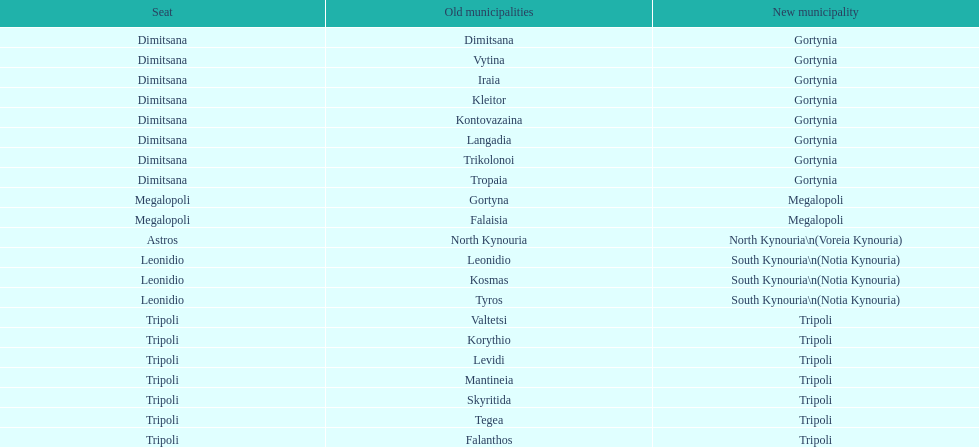What is the new municipality of tyros? South Kynouria. Help me parse the entirety of this table. {'header': ['Seat', 'Old municipalities', 'New municipality'], 'rows': [['Dimitsana', 'Dimitsana', 'Gortynia'], ['Dimitsana', 'Vytina', 'Gortynia'], ['Dimitsana', 'Iraia', 'Gortynia'], ['Dimitsana', 'Kleitor', 'Gortynia'], ['Dimitsana', 'Kontovazaina', 'Gortynia'], ['Dimitsana', 'Langadia', 'Gortynia'], ['Dimitsana', 'Trikolonoi', 'Gortynia'], ['Dimitsana', 'Tropaia', 'Gortynia'], ['Megalopoli', 'Gortyna', 'Megalopoli'], ['Megalopoli', 'Falaisia', 'Megalopoli'], ['Astros', 'North Kynouria', 'North Kynouria\\n(Voreia Kynouria)'], ['Leonidio', 'Leonidio', 'South Kynouria\\n(Notia Kynouria)'], ['Leonidio', 'Kosmas', 'South Kynouria\\n(Notia Kynouria)'], ['Leonidio', 'Tyros', 'South Kynouria\\n(Notia Kynouria)'], ['Tripoli', 'Valtetsi', 'Tripoli'], ['Tripoli', 'Korythio', 'Tripoli'], ['Tripoli', 'Levidi', 'Tripoli'], ['Tripoli', 'Mantineia', 'Tripoli'], ['Tripoli', 'Skyritida', 'Tripoli'], ['Tripoli', 'Tegea', 'Tripoli'], ['Tripoli', 'Falanthos', 'Tripoli']]} 